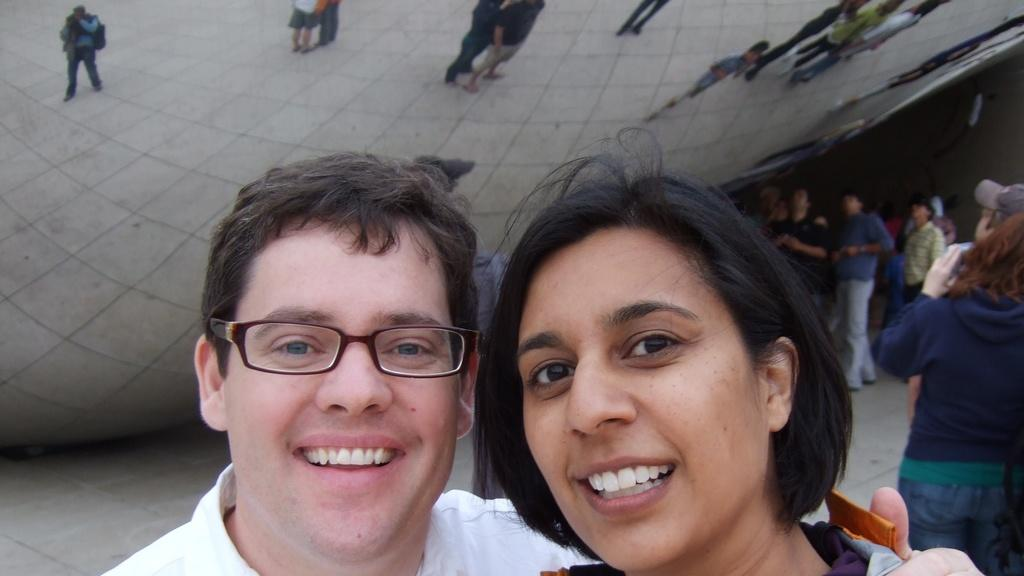How many people are in the foreground of the image? There are two persons in the foreground of the image. What can be seen in the background of the image? There is a crowd visible in the background of the image. Where is the crowd located? The crowd is on a road. Can you describe the time of day when the image was taken? The image is likely taken during the day, as there is no indication of darkness or artificial lighting. What type of letters are being exchanged between the two persons in the image? There is no indication in the image that the two persons are exchanging letters. --- Facts: 1. There is a person holding a book in the image. 2. The book has a red cover. 3. The person is sitting on a chair. 4. There is a table next to the chair. 5. The table has a lamp on it. Absurd Topics: ocean, dance, fireworks Conversation: What is the person holding in the image? The person is holding a book in the image. Can you describe the book's appearance? The book has a red cover. What is the person's seating arrangement in the image? The person is sitting on a chair. What is located next to the chair? There is a table next to the chair. What is on the table? The table has a lamp on it. Reasoning: Let's think step by step in order to produce the conversation. We start by identifying the main subject in the image, which is the person holding a book. Then, we describe the book's appearance and the person's seating arrangement. Next, we mention the presence of a table and its contents, which include a lamp. Each question is designed to elicit a specific detail about the image that is known from the provided facts. Absurd Question/Answer: Can you see any fireworks in the image? There are no fireworks present in the image. 